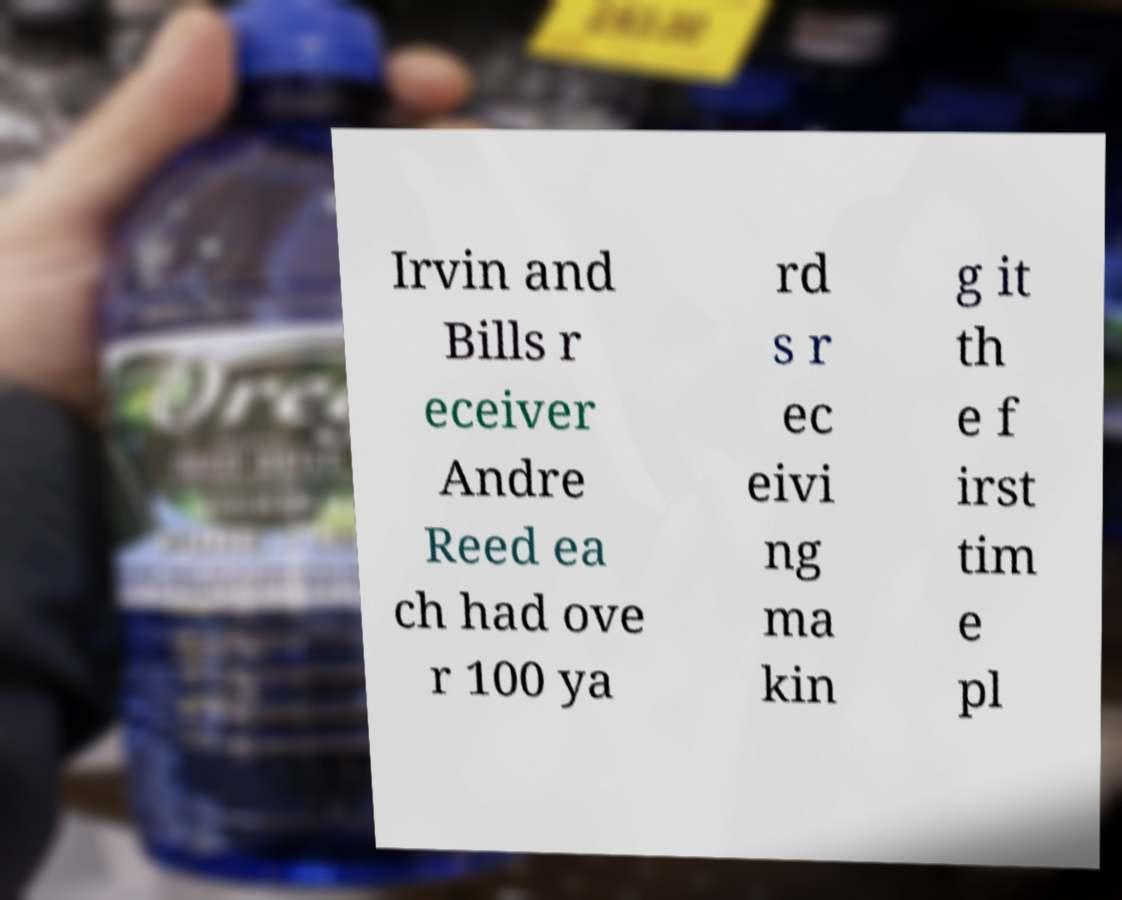I need the written content from this picture converted into text. Can you do that? Irvin and Bills r eceiver Andre Reed ea ch had ove r 100 ya rd s r ec eivi ng ma kin g it th e f irst tim e pl 